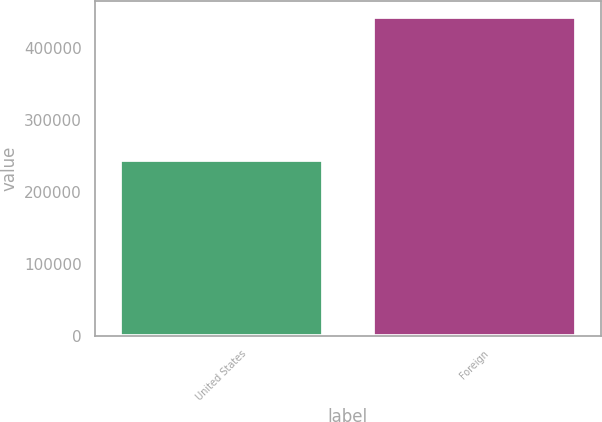Convert chart to OTSL. <chart><loc_0><loc_0><loc_500><loc_500><bar_chart><fcel>United States<fcel>Foreign<nl><fcel>243754<fcel>443102<nl></chart> 